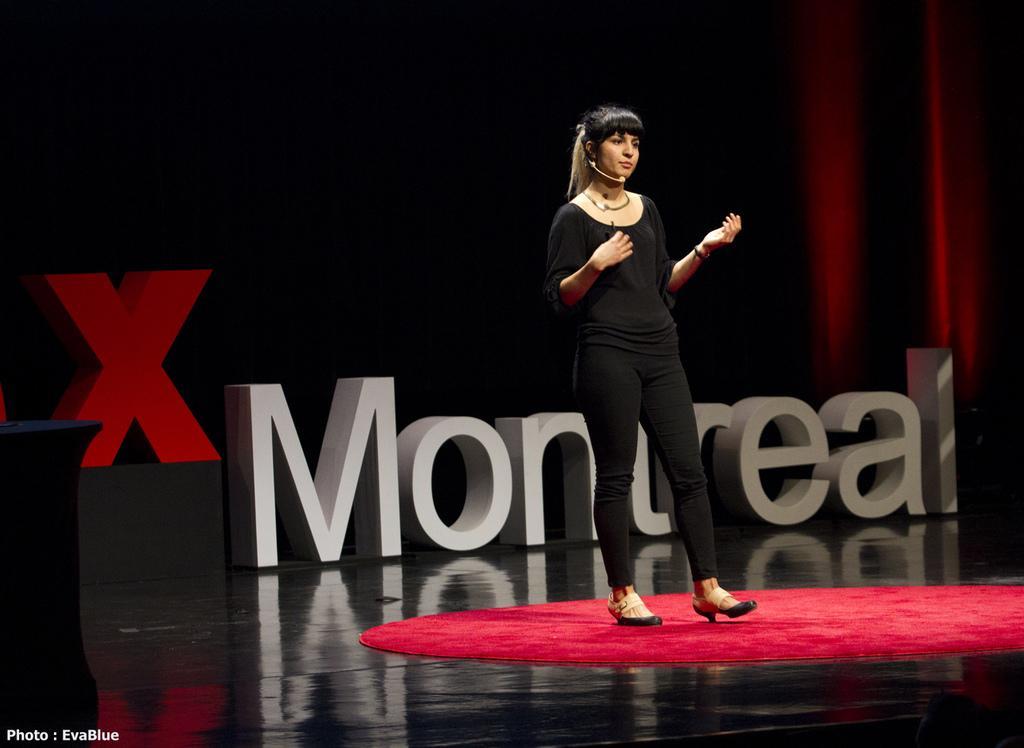Could you give a brief overview of what you see in this image? There is a lady standing and having a mic. On the floor there is red carpet. In the back something is written. And there is a watermark in the left bottom corner. 